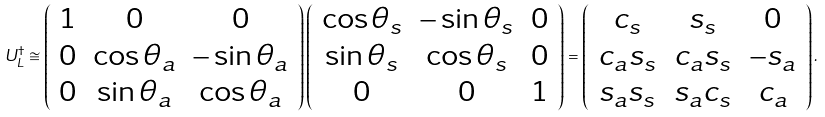Convert formula to latex. <formula><loc_0><loc_0><loc_500><loc_500>U _ { L } ^ { \dag } \cong \left ( \begin{array} { c c c } 1 & 0 & 0 \\ 0 & \cos \theta _ { a } & - \sin \theta _ { a } \\ 0 & \sin \theta _ { a } & \cos \theta _ { a } \end{array} \right ) \left ( \begin{array} { c c c } \cos \theta _ { s } & - \sin \theta _ { s } & 0 \\ \sin \theta _ { s } & \cos \theta _ { s } & 0 \\ 0 & 0 & 1 \end{array} \right ) = \left ( \begin{array} { c c c } c _ { s } & s _ { s } & 0 \\ c _ { a } s _ { s } & c _ { a } s _ { s } & - s _ { a } \\ s _ { a } s _ { s } & s _ { a } c _ { s } & c _ { a } \end{array} \right ) .</formula> 